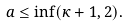Convert formula to latex. <formula><loc_0><loc_0><loc_500><loc_500>a \leq \inf ( \kappa + 1 , 2 ) .</formula> 